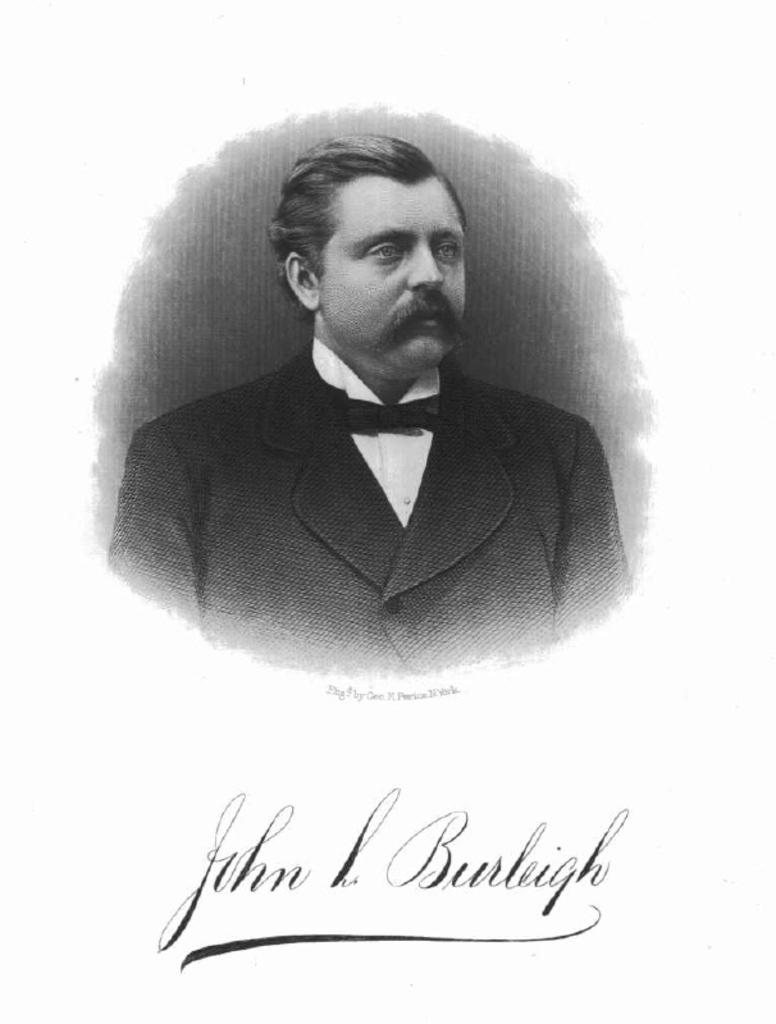What is the main subject of the image? The main subject of the image is a man. What is the man wearing in the image? The man is wearing a coat and a bow tie. Is there any text visible in the image? Yes, there is text visible in the image. What type of fruit is the man holding in the image? There is no fruit present in the image, and therefore no such activity can be observed. Is the man making a wish in the image? There is no indication in the image that the man is making a wish. 